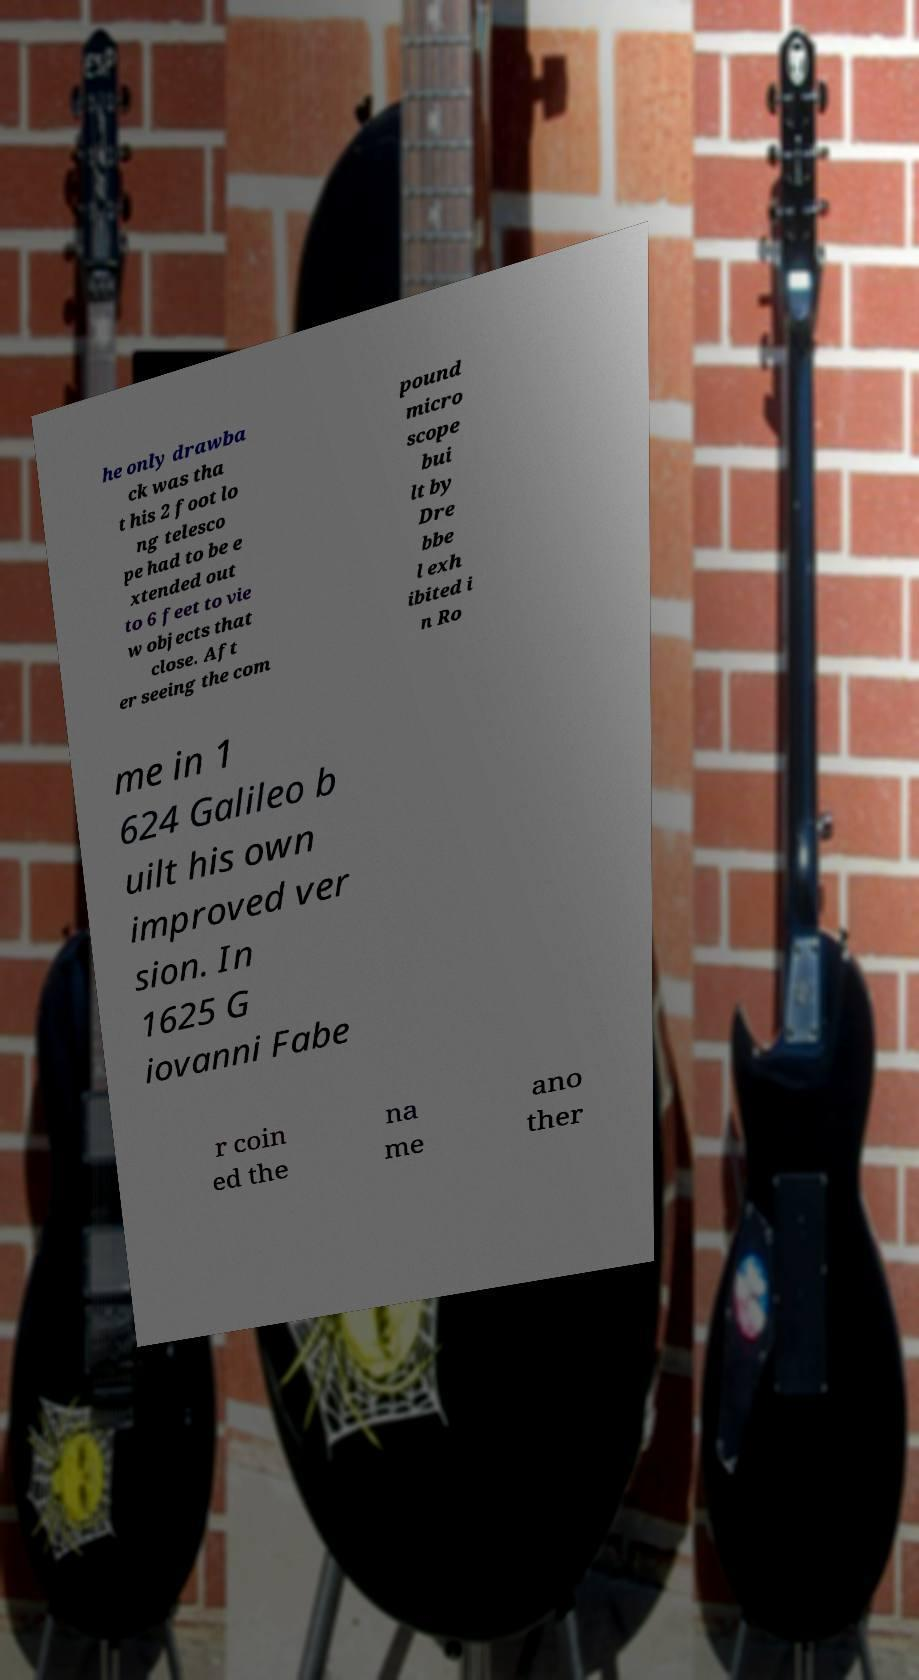What messages or text are displayed in this image? I need them in a readable, typed format. he only drawba ck was tha t his 2 foot lo ng telesco pe had to be e xtended out to 6 feet to vie w objects that close. Aft er seeing the com pound micro scope bui lt by Dre bbe l exh ibited i n Ro me in 1 624 Galileo b uilt his own improved ver sion. In 1625 G iovanni Fabe r coin ed the na me ano ther 